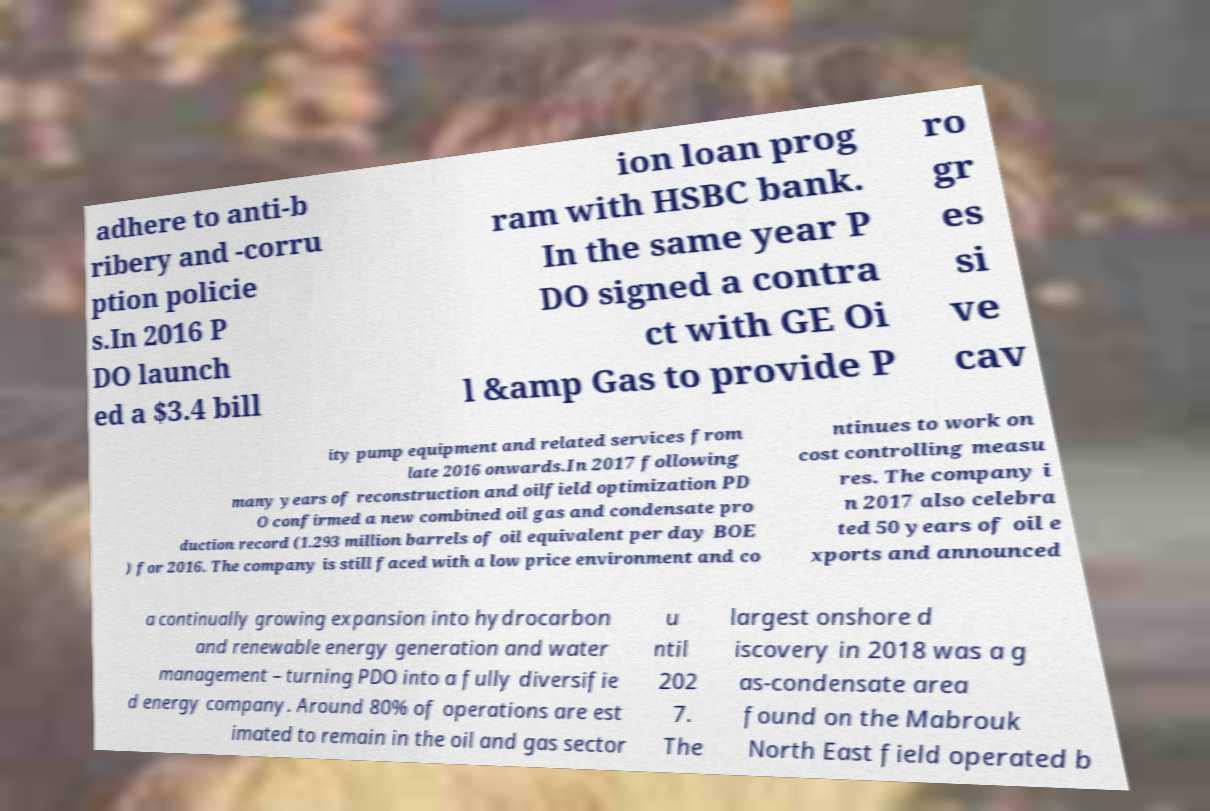I need the written content from this picture converted into text. Can you do that? adhere to anti-b ribery and -corru ption policie s.In 2016 P DO launch ed a $3.4 bill ion loan prog ram with HSBC bank. In the same year P DO signed a contra ct with GE Oi l &amp Gas to provide P ro gr es si ve cav ity pump equipment and related services from late 2016 onwards.In 2017 following many years of reconstruction and oilfield optimization PD O confirmed a new combined oil gas and condensate pro duction record (1.293 million barrels of oil equivalent per day BOE ) for 2016. The company is still faced with a low price environment and co ntinues to work on cost controlling measu res. The company i n 2017 also celebra ted 50 years of oil e xports and announced a continually growing expansion into hydrocarbon and renewable energy generation and water management – turning PDO into a fully diversifie d energy company. Around 80% of operations are est imated to remain in the oil and gas sector u ntil 202 7. The largest onshore d iscovery in 2018 was a g as-condensate area found on the Mabrouk North East field operated b 